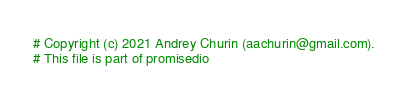<code> <loc_0><loc_0><loc_500><loc_500><_Python_># Copyright (c) 2021 Andrey Churin (aachurin@gmail.com).
# This file is part of promisedio

</code> 